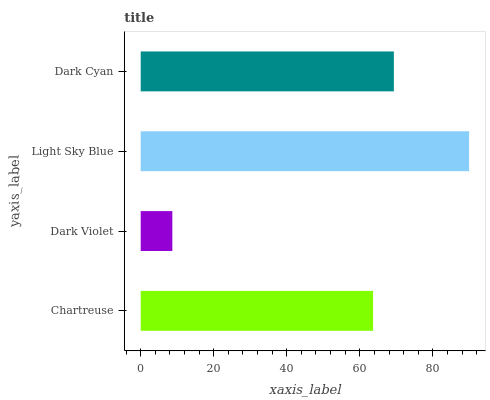Is Dark Violet the minimum?
Answer yes or no. Yes. Is Light Sky Blue the maximum?
Answer yes or no. Yes. Is Light Sky Blue the minimum?
Answer yes or no. No. Is Dark Violet the maximum?
Answer yes or no. No. Is Light Sky Blue greater than Dark Violet?
Answer yes or no. Yes. Is Dark Violet less than Light Sky Blue?
Answer yes or no. Yes. Is Dark Violet greater than Light Sky Blue?
Answer yes or no. No. Is Light Sky Blue less than Dark Violet?
Answer yes or no. No. Is Dark Cyan the high median?
Answer yes or no. Yes. Is Chartreuse the low median?
Answer yes or no. Yes. Is Light Sky Blue the high median?
Answer yes or no. No. Is Dark Violet the low median?
Answer yes or no. No. 